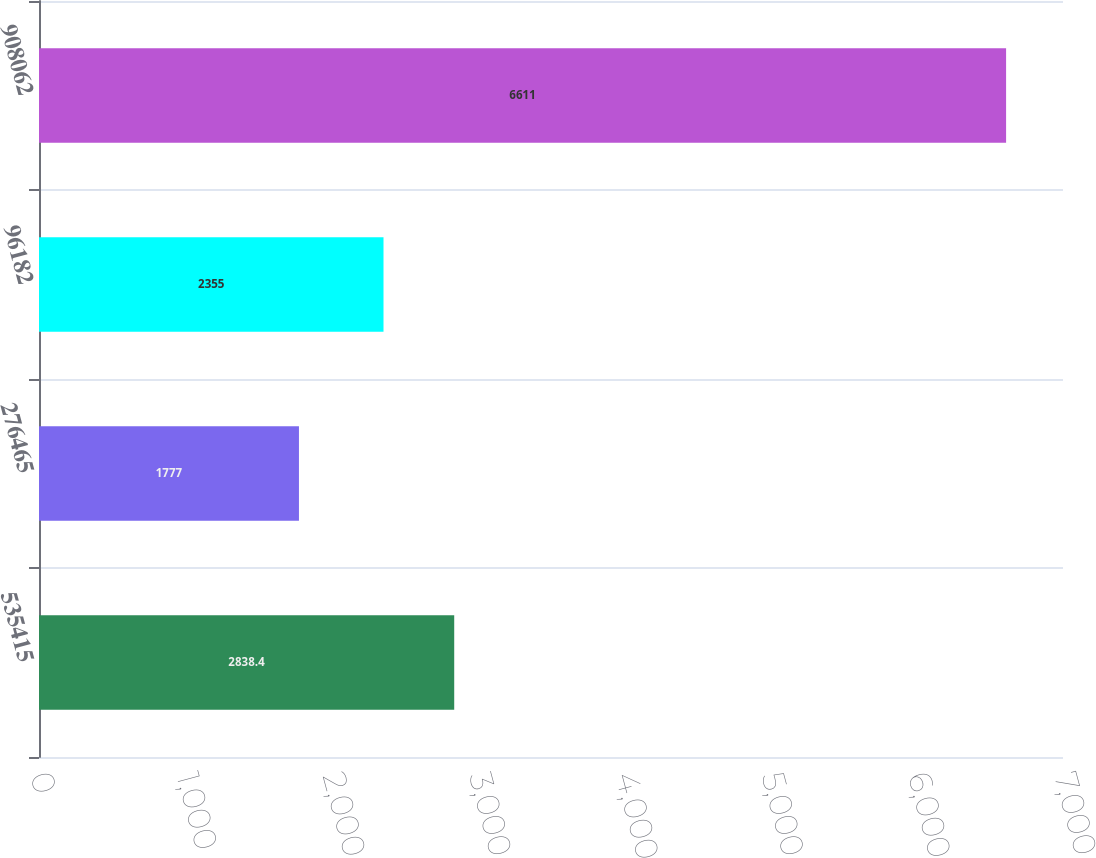Convert chart. <chart><loc_0><loc_0><loc_500><loc_500><bar_chart><fcel>535415<fcel>276465<fcel>96182<fcel>908062<nl><fcel>2838.4<fcel>1777<fcel>2355<fcel>6611<nl></chart> 